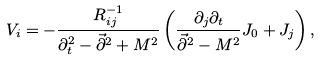Convert formula to latex. <formula><loc_0><loc_0><loc_500><loc_500>V _ { i } = - { \frac { R _ { i j } ^ { - 1 } } { \partial _ { t } ^ { 2 } - \vec { \partial } ^ { 2 } + M ^ { 2 } } } \left ( { \frac { \partial _ { j } \partial _ { t } } { \vec { \partial } ^ { 2 } - M ^ { 2 } } } J _ { 0 } + J _ { j } \right ) ,</formula> 